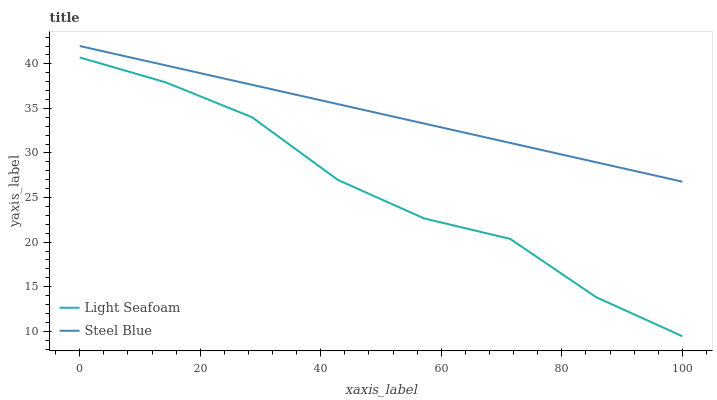Does Light Seafoam have the minimum area under the curve?
Answer yes or no. Yes. Does Steel Blue have the maximum area under the curve?
Answer yes or no. Yes. Does Steel Blue have the minimum area under the curve?
Answer yes or no. No. Is Steel Blue the smoothest?
Answer yes or no. Yes. Is Light Seafoam the roughest?
Answer yes or no. Yes. Is Steel Blue the roughest?
Answer yes or no. No. Does Light Seafoam have the lowest value?
Answer yes or no. Yes. Does Steel Blue have the lowest value?
Answer yes or no. No. Does Steel Blue have the highest value?
Answer yes or no. Yes. Is Light Seafoam less than Steel Blue?
Answer yes or no. Yes. Is Steel Blue greater than Light Seafoam?
Answer yes or no. Yes. Does Light Seafoam intersect Steel Blue?
Answer yes or no. No. 